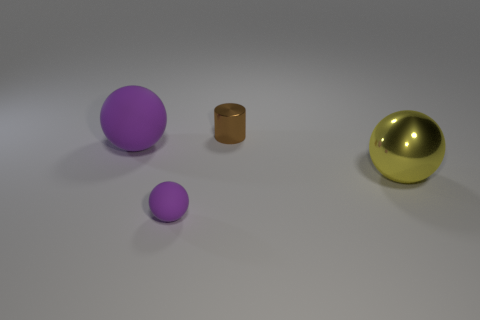What is the shape of the matte thing that is the same color as the tiny matte ball?
Ensure brevity in your answer.  Sphere. What size is the other ball that is made of the same material as the big purple ball?
Provide a short and direct response. Small. Is the number of cylinders that are left of the big rubber object greater than the number of purple spheres?
Provide a succinct answer. No. There is a tiny brown metallic object; does it have the same shape as the tiny thing in front of the tiny brown thing?
Provide a succinct answer. No. How many tiny things are either brown things or yellow shiny spheres?
Provide a short and direct response. 1. There is a ball that is the same color as the big rubber object; what is its size?
Make the answer very short. Small. The tiny shiny thing that is to the left of the shiny thing that is right of the small brown shiny cylinder is what color?
Keep it short and to the point. Brown. Are the small brown cylinder and the purple sphere that is behind the large shiny sphere made of the same material?
Keep it short and to the point. No. What is the purple object right of the large rubber ball made of?
Your answer should be very brief. Rubber. Are there an equal number of tiny purple rubber spheres that are behind the tiny brown shiny thing and big purple spheres?
Provide a short and direct response. No. 